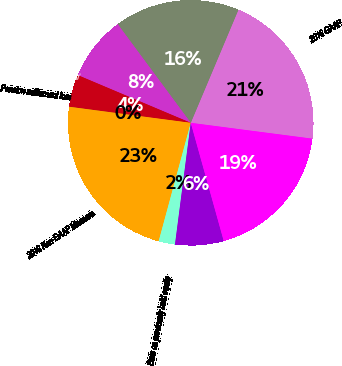Convert chart to OTSL. <chart><loc_0><loc_0><loc_500><loc_500><pie_chart><fcel>2016 GAAP<fcel>2015 GAAP<fcel>Business separation costs (C)<fcel>Business restructuring and<fcel>Pension settlement loss<fcel>2016 Non-GAAP Measure<fcel>Gain on previously held equity<fcel>Gain on land sales (E)<fcel>2015 Non-GAAP Measure<nl><fcel>20.71%<fcel>16.49%<fcel>8.49%<fcel>4.27%<fcel>0.05%<fcel>22.82%<fcel>2.16%<fcel>6.38%<fcel>18.6%<nl></chart> 